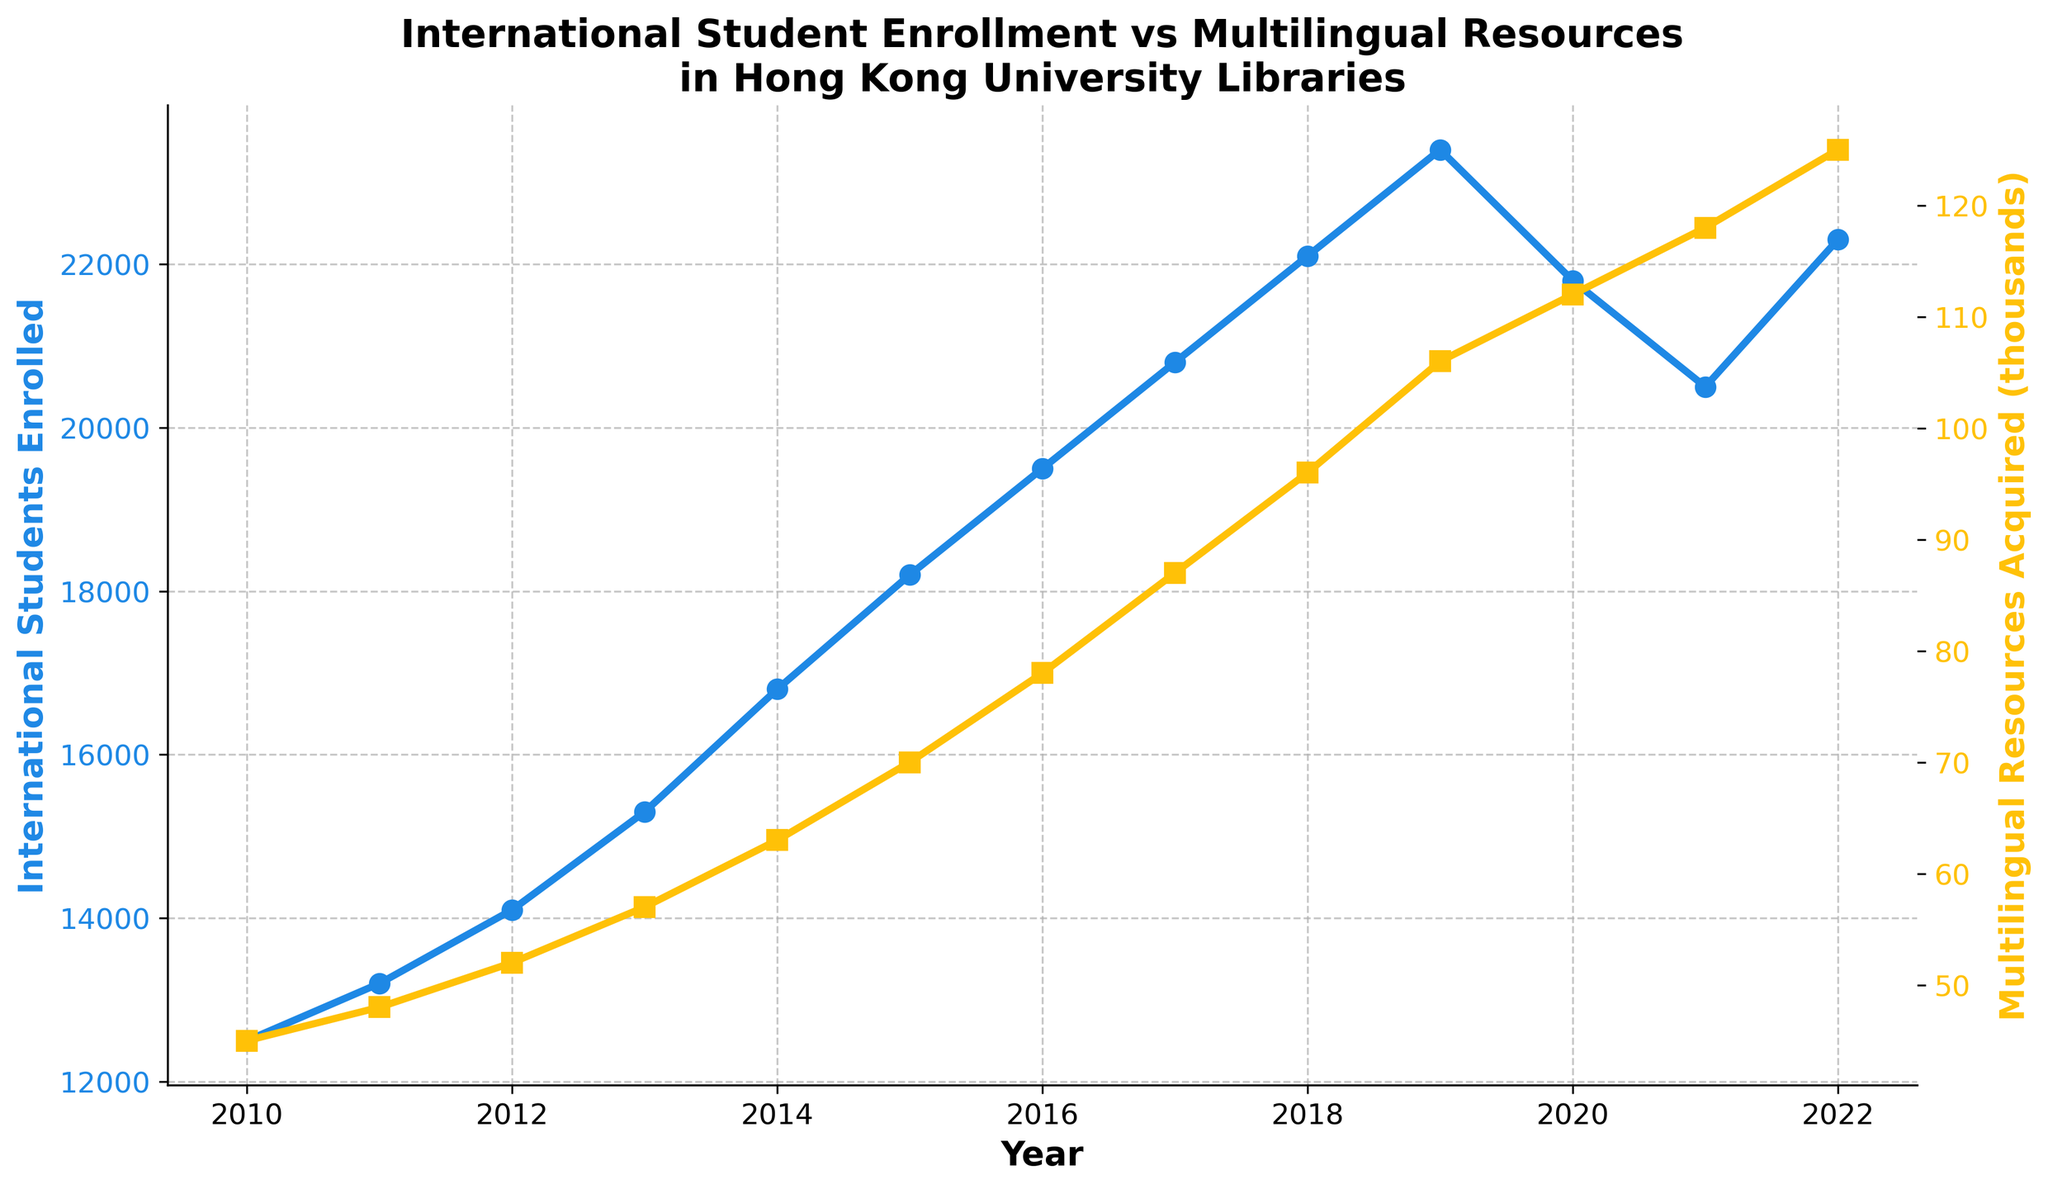What's the trend in international student enrollment from 2010 to 2022? The trend in international student enrollment can be seen by observing the line for international students. It increases steadily from 2010 (12,500) to 2019 (23,400), with a dip in 2020 (21,800) and 2021 (20,500), followed by a recovery in 2022 (22,300).
Answer: Steady increase with a dip in 2020-2021 Which year saw the highest number of multilingual resources acquired? Look at the line representing multilingual resources acquired and find the peak point. The highest number is seen in 2022, with 125,000 resources acquired.
Answer: 2022 How did the number of international students change between 2019 and 2021? Identify the values for 2019, 2020, and 2021 for international students. The number decreased from 23,400 in 2019 to 21,800 in 2020 and then to 20,500 in 2021.
Answer: Decreased Compare the number of international students enrolled in 2013 and 2018. Which year had more students? Check the values for 2013 (15,300) and 2018 (22,100) on the international students line.
Answer: 2018 What is the difference in the number of multilingual resources acquired between 2010 and 2022? Find the values for multilingual resources for 2010 (45,000) and 2022 (125,000). Subtract the 2010 value from the 2022 value: 125,000 - 45,000.
Answer: 80,000 What can you say about the relationship between the trends in international student enrollment and multilingual resources acquisition? Examine both lines over the years. Both show a general increase over time, with a slight dip in international student enrollment during 2020-2021. However, multilingual resources acquisition steadily increased each year.
Answer: Both generally increase, but enrollment dips in 2020-2021 Which two consecutive years saw the largest increase in international student enrollment? Calculate the difference in international student enrollment for each pair of consecutive years. The pairs and their differences are: 2010-2011 (700), 2011-2012 (900), 2012-2013 (1,200), 2013-2014 (1,500), 2014-2015 (1,400), 2015-2016 (1,300), 2016-2017 (1,300), 2017-2018 (1,300), 2018-2019 (1,300), 2019-2020 (-1,600), 2020-2021 (-1,300), 2021-2022 (1,800). The largest increase is between 2021 and 2022 (1,800).
Answer: 2021-2022 By how much did the acquisition of multilingual resources grow from 2015 to 2020? Identify the values for 2015 (70,000) and 2020 (112,000) for multilingual resources. Subtract the 2015 value from the 2020 value: 112,000 - 70,000.
Answer: 42,000 What is the yearly average increase in multilingual resources from 2010 to 2022? Calculate the total increase by subtracting the 2010 value from the 2022 value: 125,000 - 45,000 = 80,000. Then, divide by the number of years (2022 – 2010) = 12. The average yearly increase is 80,000 / 12.
Answer: Approximately 6,667 Is there any visual indication that the two metrics (international student enrollment and multilingual resources acquisition) are related? Both lines generally trend upward, suggesting a positive correlation where increasing international student enrollment might drive or correlate with increased multilingual resource acquisition.
Answer: Positive correlation Compare the overall trends of international student enrollment and multilingual resource acquisition. Are there any periods where the trends differ significantly? Observe both lines from 2010 to 2022. Both metrics generally increase, but international student enrollment decreases during 2020-2021, whereas multilingual resource acquisition continues to increase without dips.
Answer: 2020-2021 